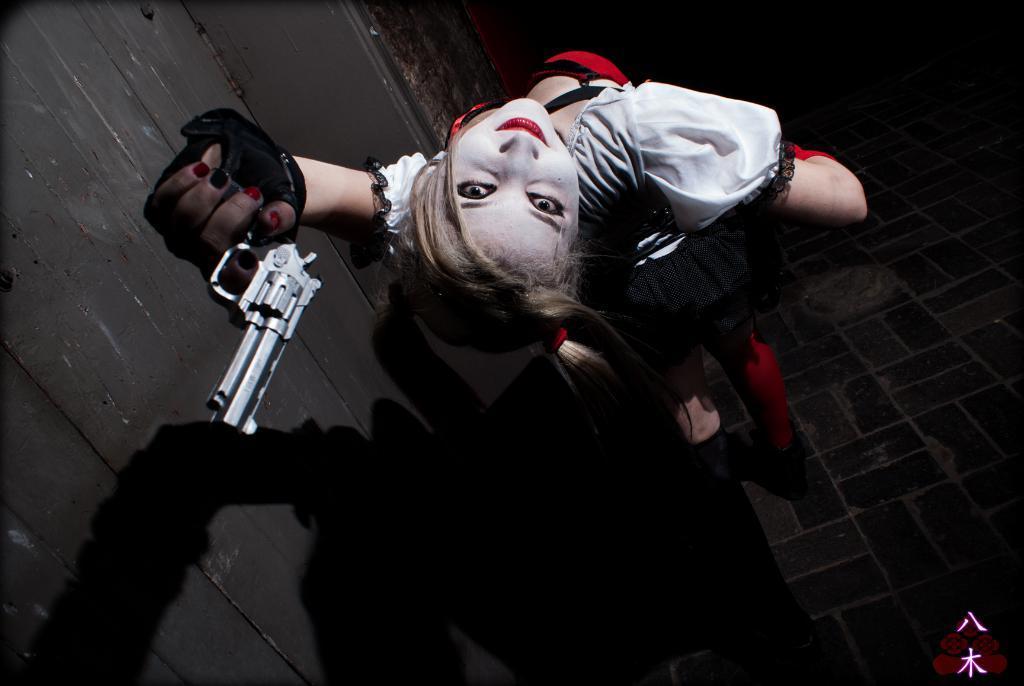Can you describe this image briefly? In this image we can see a woman standing and holding a gun, on the left side of the image we can see the wall and the background is dark. 